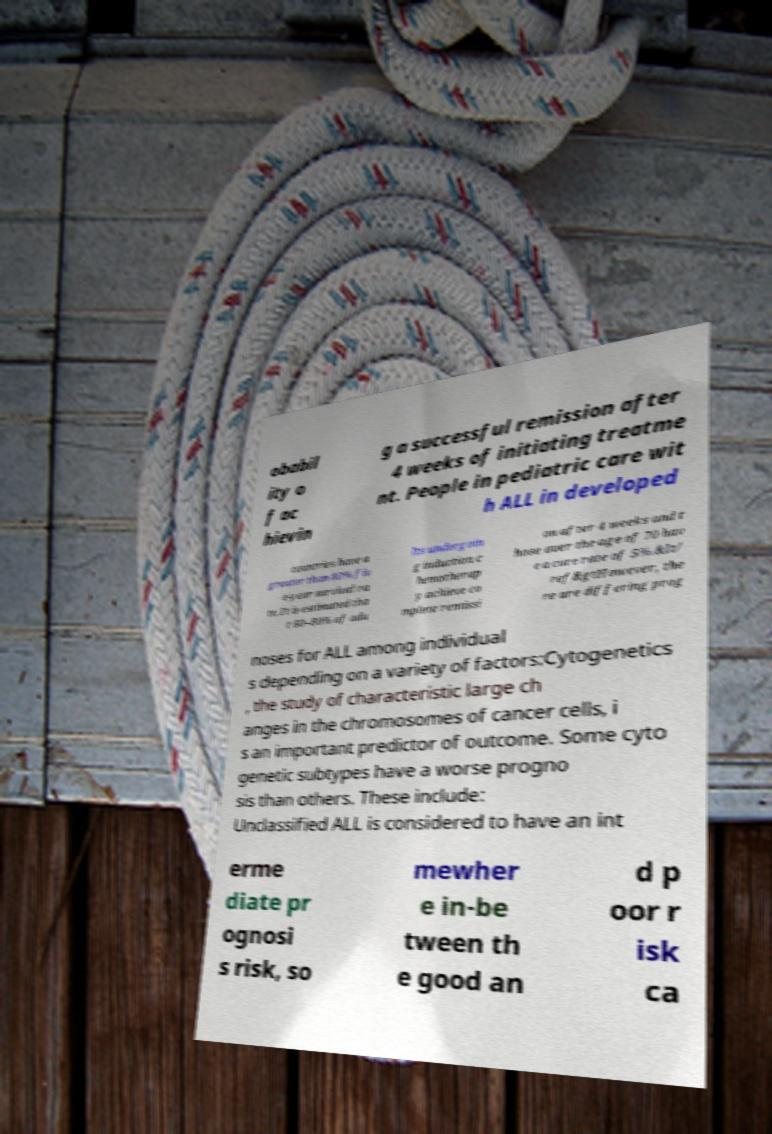There's text embedded in this image that I need extracted. Can you transcribe it verbatim? obabil ity o f ac hievin g a successful remission after 4 weeks of initiating treatme nt. People in pediatric care wit h ALL in developed countries have a greater than 80% fiv e-year survival ra te. It is estimated tha t 60–80% of adu lts undergoin g induction c hemotherap y achieve co mplete remissi on after 4 weeks and t hose over the age of 70 hav e a cure rate of 5%.&lt/ ref&gtHowever, the re are differing prog noses for ALL among individual s depending on a variety of factors:Cytogenetics , the study of characteristic large ch anges in the chromosomes of cancer cells, i s an important predictor of outcome. Some cyto genetic subtypes have a worse progno sis than others. These include: Unclassified ALL is considered to have an int erme diate pr ognosi s risk, so mewher e in-be tween th e good an d p oor r isk ca 